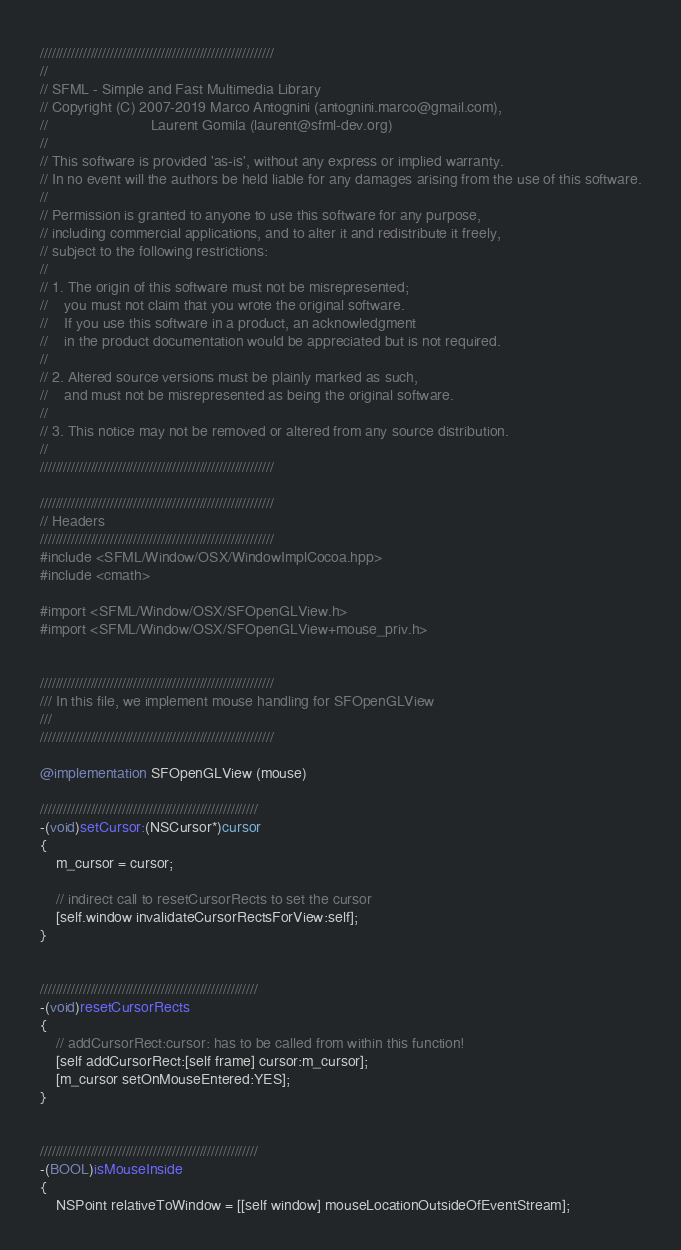Convert code to text. <code><loc_0><loc_0><loc_500><loc_500><_ObjectiveC_>////////////////////////////////////////////////////////////
//
// SFML - Simple and Fast Multimedia Library
// Copyright (C) 2007-2019 Marco Antognini (antognini.marco@gmail.com),
//                         Laurent Gomila (laurent@sfml-dev.org)
//
// This software is provided 'as-is', without any express or implied warranty.
// In no event will the authors be held liable for any damages arising from the use of this software.
//
// Permission is granted to anyone to use this software for any purpose,
// including commercial applications, and to alter it and redistribute it freely,
// subject to the following restrictions:
//
// 1. The origin of this software must not be misrepresented;
//    you must not claim that you wrote the original software.
//    If you use this software in a product, an acknowledgment
//    in the product documentation would be appreciated but is not required.
//
// 2. Altered source versions must be plainly marked as such,
//    and must not be misrepresented as being the original software.
//
// 3. This notice may not be removed or altered from any source distribution.
//
////////////////////////////////////////////////////////////

////////////////////////////////////////////////////////////
// Headers
////////////////////////////////////////////////////////////
#include <SFML/Window/OSX/WindowImplCocoa.hpp>
#include <cmath>

#import <SFML/Window/OSX/SFOpenGLView.h>
#import <SFML/Window/OSX/SFOpenGLView+mouse_priv.h>


////////////////////////////////////////////////////////////
/// In this file, we implement mouse handling for SFOpenGLView
///
////////////////////////////////////////////////////////////

@implementation SFOpenGLView (mouse)

////////////////////////////////////////////////////////
-(void)setCursor:(NSCursor*)cursor
{
    m_cursor = cursor;

    // indirect call to resetCursorRects to set the cursor
    [self.window invalidateCursorRectsForView:self]; 
}


////////////////////////////////////////////////////////
-(void)resetCursorRects
{
    // addCursorRect:cursor: has to be called from within this function!
    [self addCursorRect:[self frame] cursor:m_cursor];
    [m_cursor setOnMouseEntered:YES];
}


////////////////////////////////////////////////////////
-(BOOL)isMouseInside
{
    NSPoint relativeToWindow = [[self window] mouseLocationOutsideOfEventStream];</code> 